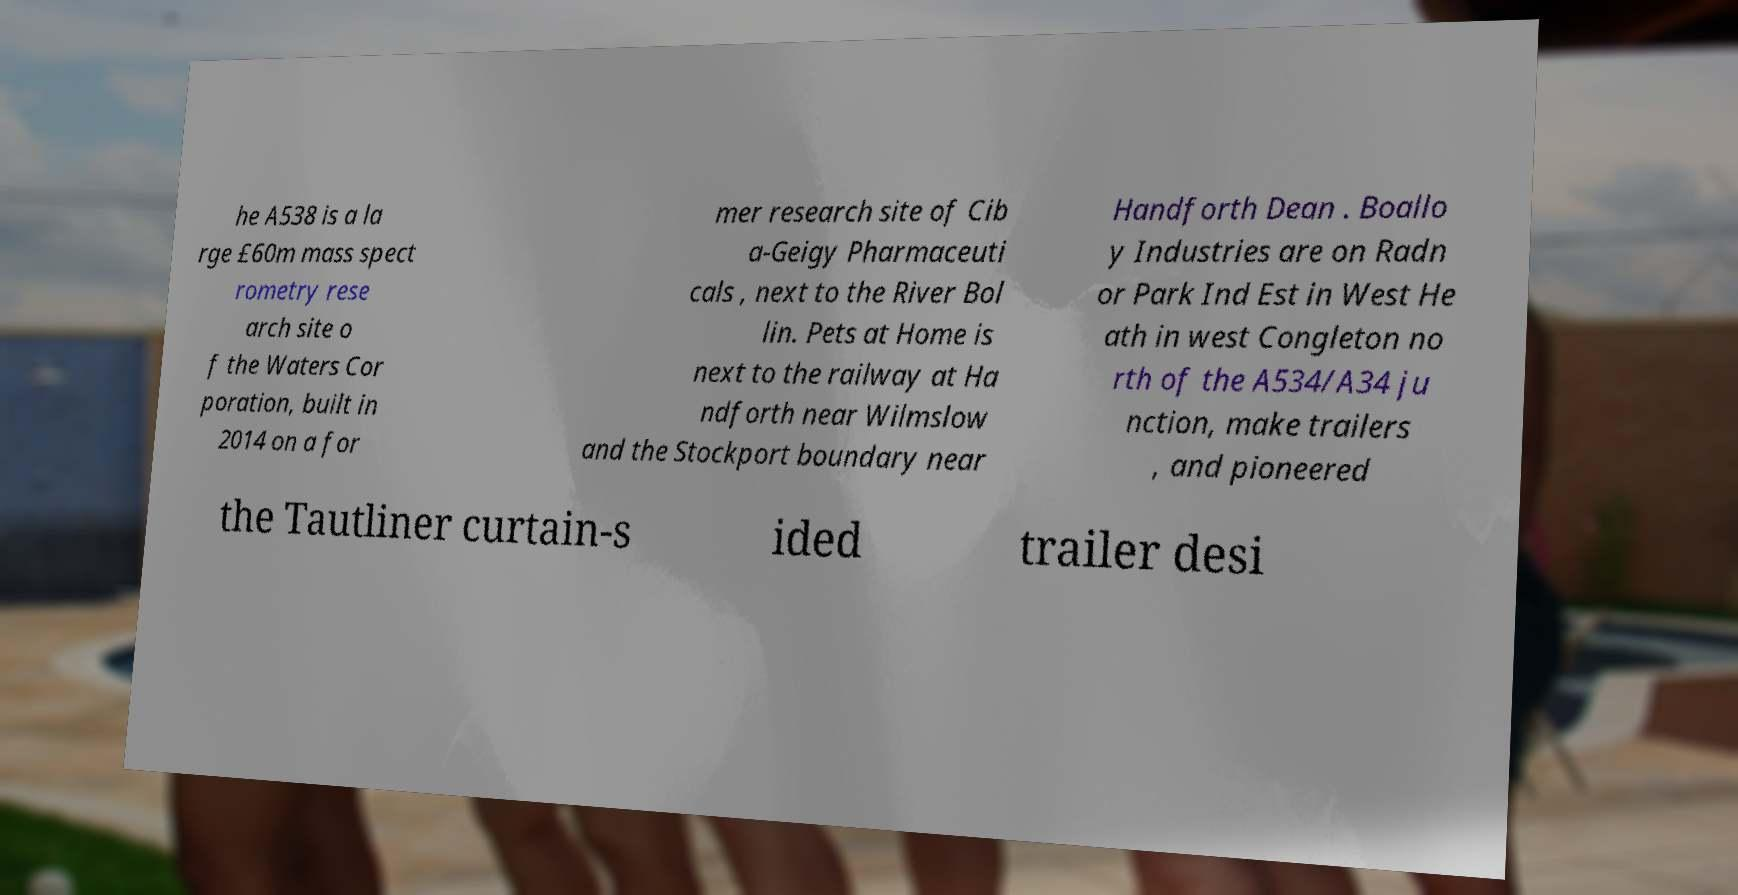Please identify and transcribe the text found in this image. he A538 is a la rge £60m mass spect rometry rese arch site o f the Waters Cor poration, built in 2014 on a for mer research site of Cib a-Geigy Pharmaceuti cals , next to the River Bol lin. Pets at Home is next to the railway at Ha ndforth near Wilmslow and the Stockport boundary near Handforth Dean . Boallo y Industries are on Radn or Park Ind Est in West He ath in west Congleton no rth of the A534/A34 ju nction, make trailers , and pioneered the Tautliner curtain-s ided trailer desi 